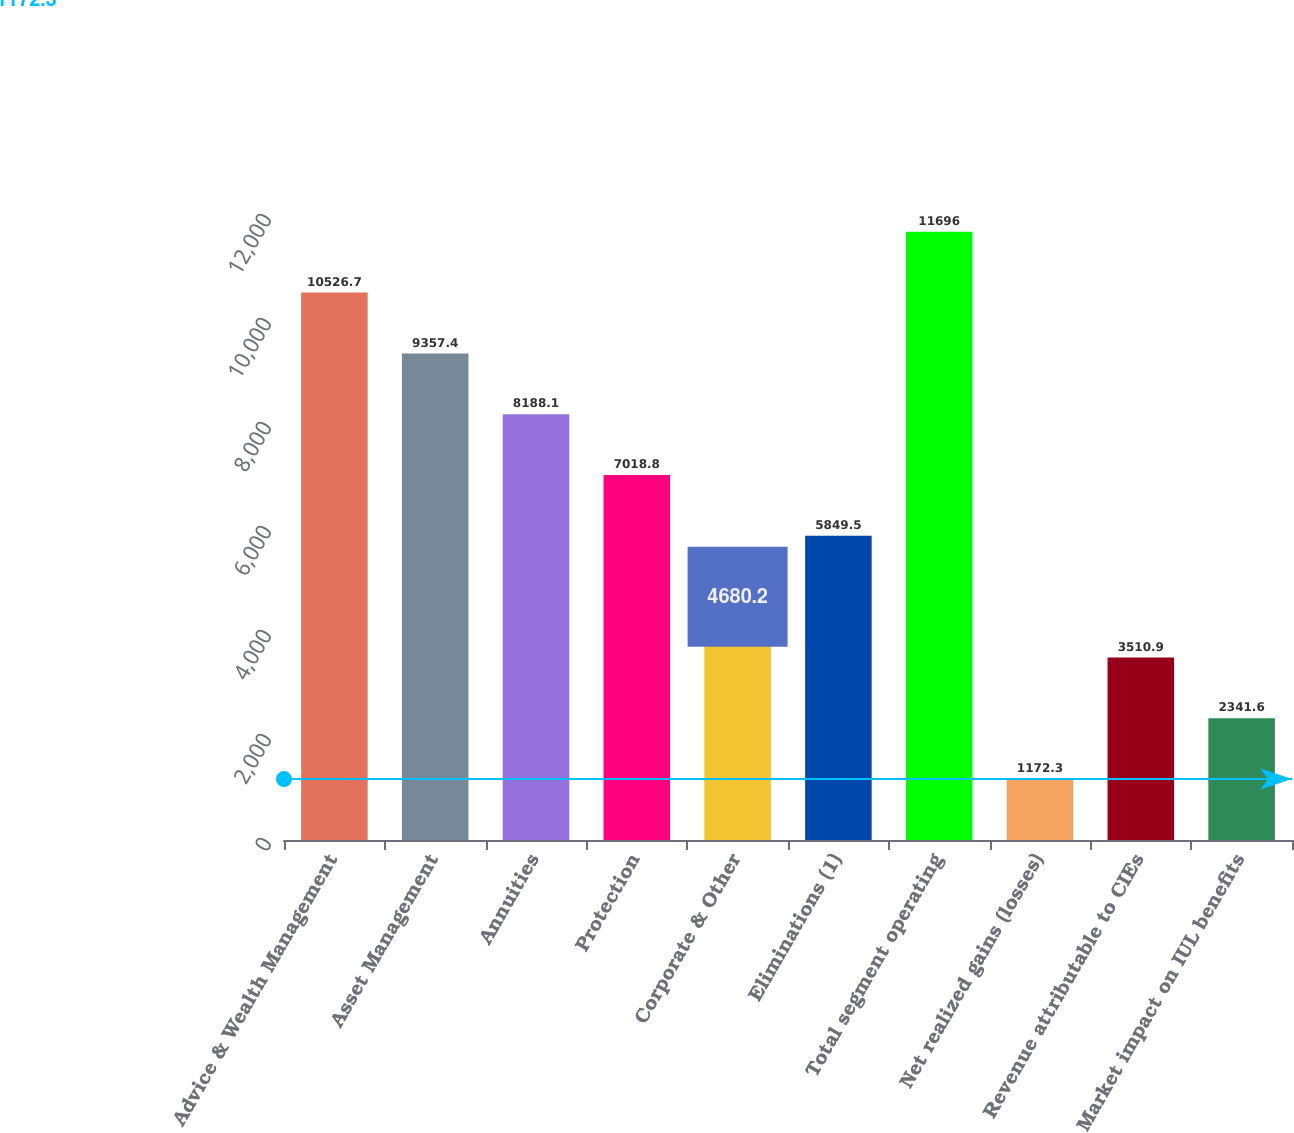Convert chart. <chart><loc_0><loc_0><loc_500><loc_500><bar_chart><fcel>Advice & Wealth Management<fcel>Asset Management<fcel>Annuities<fcel>Protection<fcel>Corporate & Other<fcel>Eliminations (1)<fcel>Total segment operating<fcel>Net realized gains (losses)<fcel>Revenue attributable to CIEs<fcel>Market impact on IUL benefits<nl><fcel>10526.7<fcel>9357.4<fcel>8188.1<fcel>7018.8<fcel>4680.2<fcel>5849.5<fcel>11696<fcel>1172.3<fcel>3510.9<fcel>2341.6<nl></chart> 